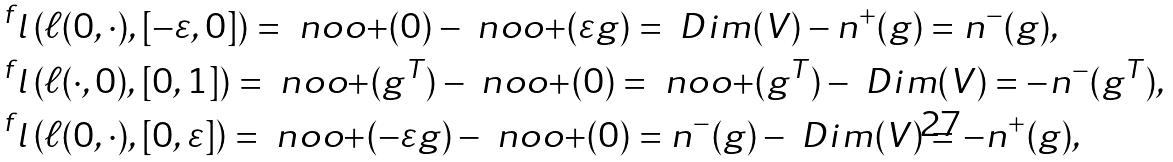Convert formula to latex. <formula><loc_0><loc_0><loc_500><loc_500>& ^ { f } l \left ( \ell ( 0 , \cdot ) , [ - \varepsilon , 0 ] \right ) = { \ n o o + } ( 0 ) - { \ n o o + } ( \varepsilon g ) = \ D i m ( V ) - n ^ { + } ( g ) = n ^ { - } ( g ) , \\ & ^ { f } l \left ( \ell ( \cdot , 0 ) , [ 0 , 1 ] \right ) = { \ n o o + } ( g ^ { T } ) - { \ n o o + } ( 0 ) = { \ n o o + } ( g ^ { T } ) - \ D i m ( V ) = - n ^ { - } ( g ^ { T } ) , \\ & ^ { f } l \left ( \ell ( 0 , \cdot ) , [ 0 , \varepsilon ] \right ) = { \ n o o + } ( - \varepsilon g ) - { \ n o o + } ( 0 ) = n ^ { - } ( g ) - \ D i m ( V ) = - n ^ { + } ( g ) ,</formula> 